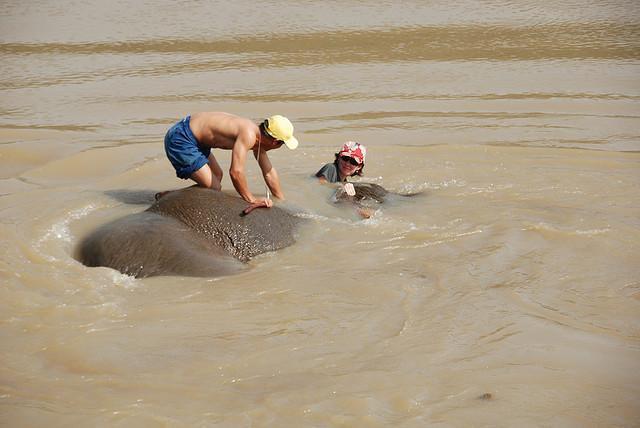How many people are pictured?
Give a very brief answer. 2. How many horses are in the photo?
Give a very brief answer. 0. 